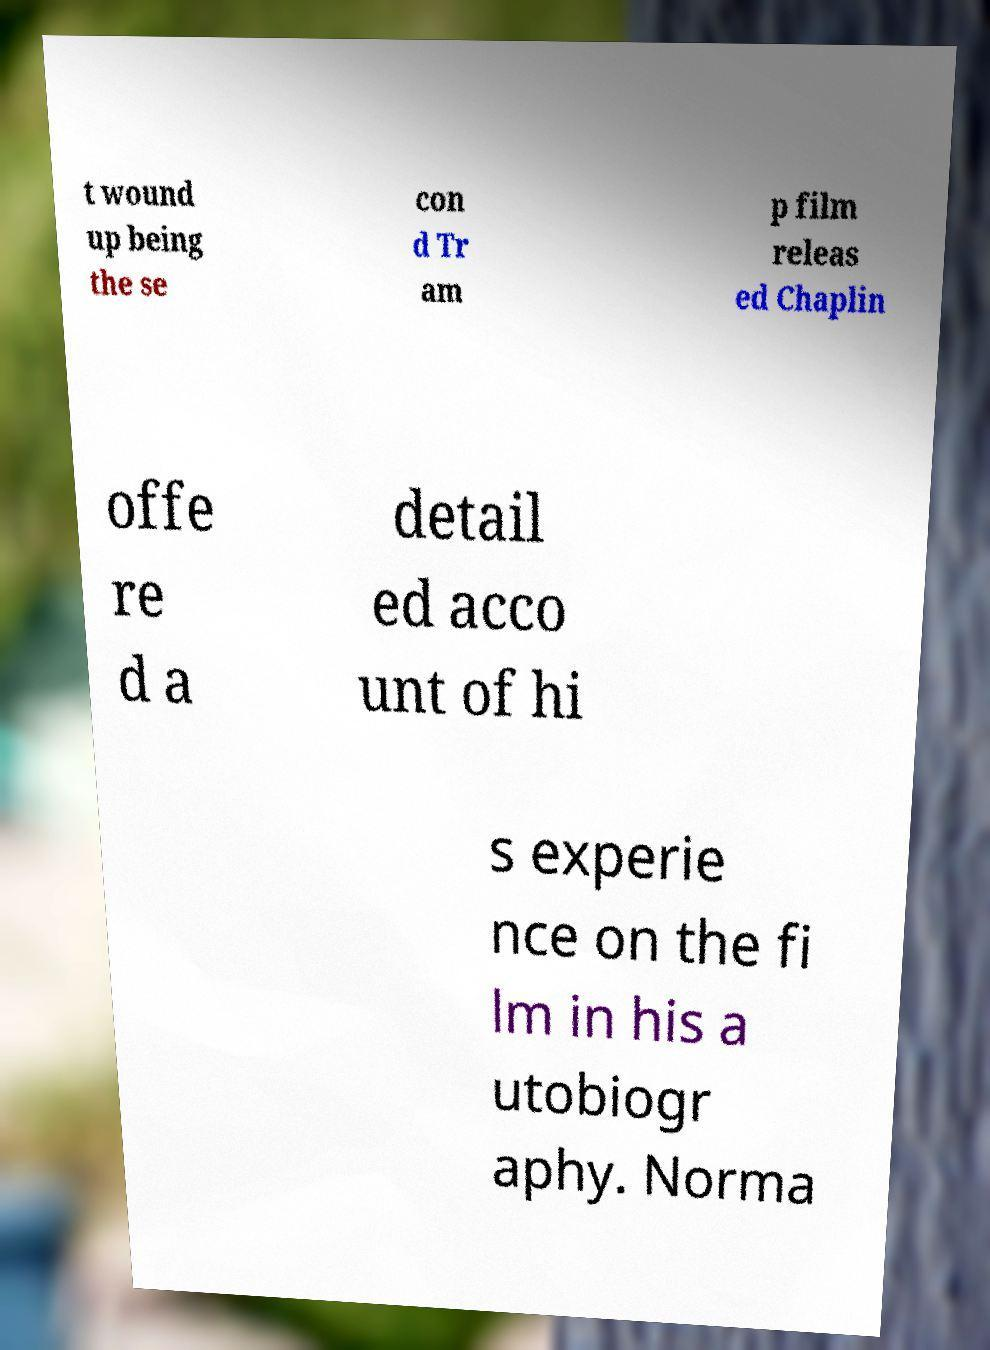Please identify and transcribe the text found in this image. t wound up being the se con d Tr am p film releas ed Chaplin offe re d a detail ed acco unt of hi s experie nce on the fi lm in his a utobiogr aphy. Norma 